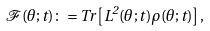Convert formula to latex. <formula><loc_0><loc_0><loc_500><loc_500>\mathcal { F } ( \theta ; t ) \colon = T r \left [ L ^ { 2 } ( \theta ; t ) \rho ( \theta ; t ) \right ] ,</formula> 